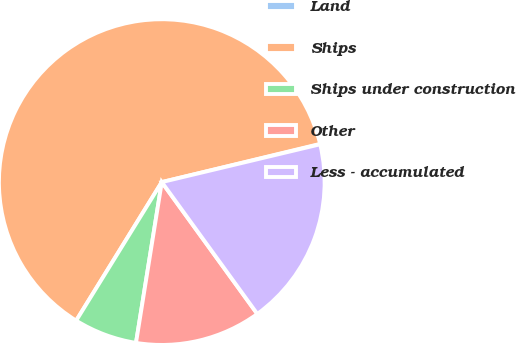Convert chart. <chart><loc_0><loc_0><loc_500><loc_500><pie_chart><fcel>Land<fcel>Ships<fcel>Ships under construction<fcel>Other<fcel>Less - accumulated<nl><fcel>0.04%<fcel>62.42%<fcel>6.28%<fcel>12.51%<fcel>18.75%<nl></chart> 